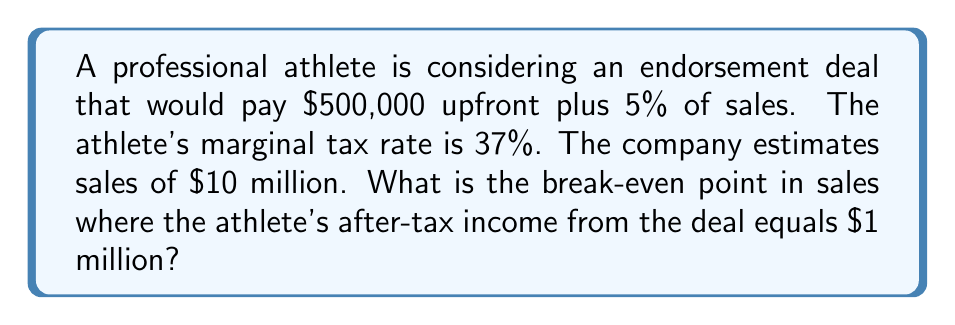Could you help me with this problem? Let's approach this step-by-step:

1) First, we need to set up an equation for the athlete's after-tax income:

   $$(500000 + 0.05x)(1 - 0.37) = 1000000$$

   Where $x$ is the sales amount in dollars.

2) Let's simplify the left side of the equation:

   $$500000(0.63) + 0.05x(0.63) = 1000000$$
   $$315000 + 0.0315x = 1000000$$

3) Now, let's solve for $x$:

   $$0.0315x = 1000000 - 315000$$
   $$0.0315x = 685000$$

4) Dividing both sides by 0.0315:

   $$x = \frac{685000}{0.0315} = 21746031.75$$

5) Rounding to the nearest dollar:

   $$x = 21746032$$

This means the athlete needs the company to achieve $21,746,032 in sales for their after-tax income from the deal to equal $1 million.

6) We can verify:
   $$(500000 + 0.05(21746032))(1 - 0.37)$$
   $$(500000 + 1087301.60)(0.63)$$
   $$(1587301.60)(0.63) = 1000000.01$$

   The slight difference is due to rounding.
Answer: $21,746,032 